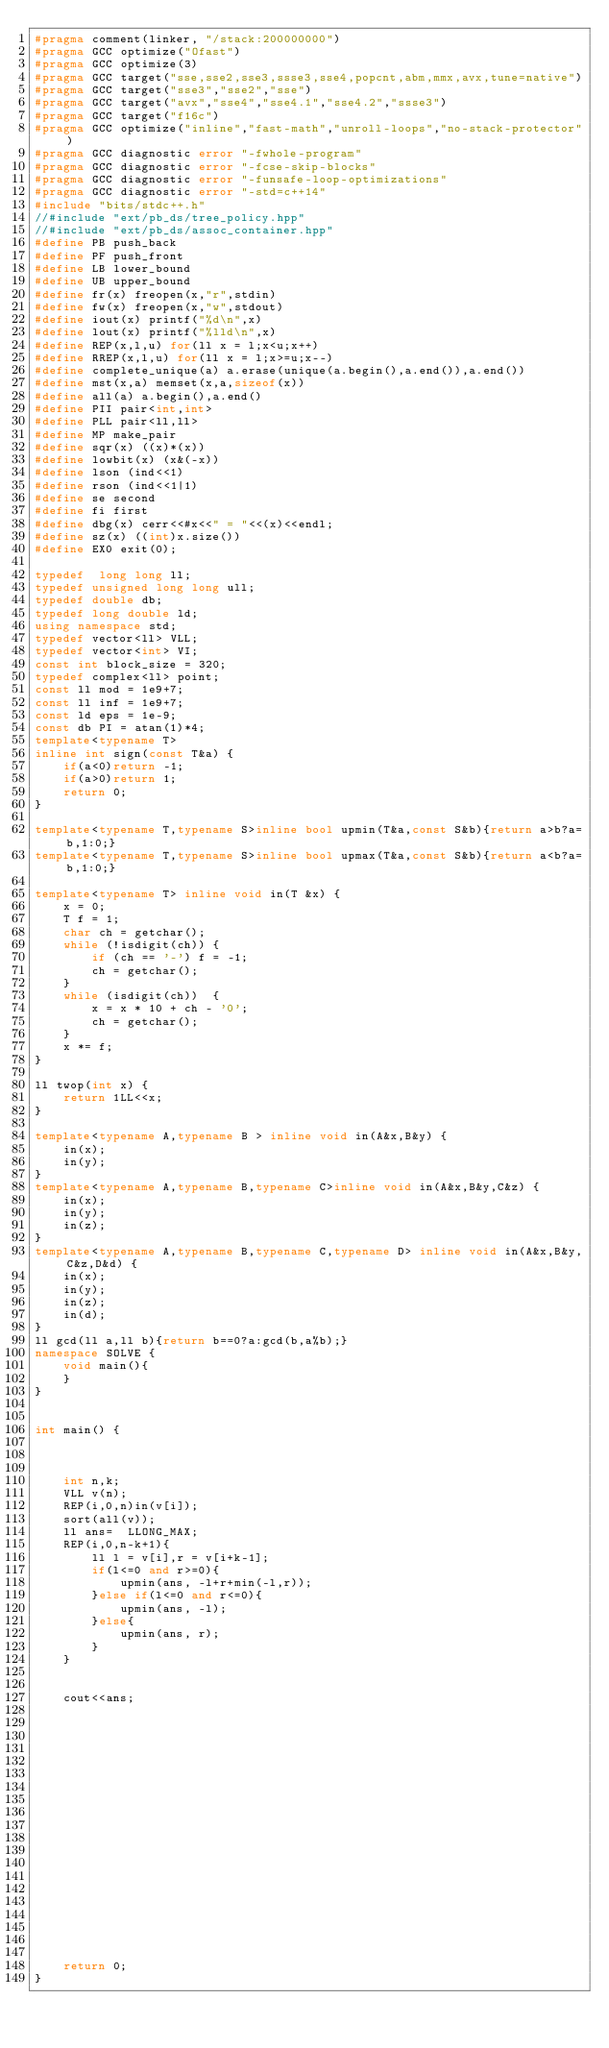<code> <loc_0><loc_0><loc_500><loc_500><_C++_>#pragma comment(linker, "/stack:200000000")
#pragma GCC optimize("Ofast")
#pragma GCC optimize(3)
#pragma GCC target("sse,sse2,sse3,ssse3,sse4,popcnt,abm,mmx,avx,tune=native")
#pragma GCC target("sse3","sse2","sse")
#pragma GCC target("avx","sse4","sse4.1","sse4.2","ssse3")
#pragma GCC target("f16c")
#pragma GCC optimize("inline","fast-math","unroll-loops","no-stack-protector")
#pragma GCC diagnostic error "-fwhole-program"
#pragma GCC diagnostic error "-fcse-skip-blocks"
#pragma GCC diagnostic error "-funsafe-loop-optimizations"
#pragma GCC diagnostic error "-std=c++14"
#include "bits/stdc++.h"
//#include "ext/pb_ds/tree_policy.hpp"
//#include "ext/pb_ds/assoc_container.hpp"
#define PB push_back
#define PF push_front
#define LB lower_bound
#define UB upper_bound
#define fr(x) freopen(x,"r",stdin)
#define fw(x) freopen(x,"w",stdout)
#define iout(x) printf("%d\n",x)
#define lout(x) printf("%lld\n",x)
#define REP(x,l,u) for(ll x = l;x<u;x++)
#define RREP(x,l,u) for(ll x = l;x>=u;x--)
#define complete_unique(a) a.erase(unique(a.begin(),a.end()),a.end())
#define mst(x,a) memset(x,a,sizeof(x))
#define all(a) a.begin(),a.end()
#define PII pair<int,int>
#define PLL pair<ll,ll>
#define MP make_pair
#define sqr(x) ((x)*(x))
#define lowbit(x) (x&(-x))
#define lson (ind<<1)
#define rson (ind<<1|1)
#define se second
#define fi first
#define dbg(x) cerr<<#x<<" = "<<(x)<<endl;
#define sz(x) ((int)x.size())
#define EX0 exit(0);

typedef  long long ll;
typedef unsigned long long ull;
typedef double db;
typedef long double ld;
using namespace std;
typedef vector<ll> VLL;
typedef vector<int> VI;
const int block_size = 320;
typedef complex<ll> point;
const ll mod = 1e9+7;
const ll inf = 1e9+7;
const ld eps = 1e-9;
const db PI = atan(1)*4;
template<typename T>
inline int sign(const T&a) {
    if(a<0)return -1;
    if(a>0)return 1;
    return 0;
}

template<typename T,typename S>inline bool upmin(T&a,const S&b){return a>b?a=b,1:0;}
template<typename T,typename S>inline bool upmax(T&a,const S&b){return a<b?a=b,1:0;}

template<typename T> inline void in(T &x) {
    x = 0;
    T f = 1;
    char ch = getchar();
    while (!isdigit(ch)) {
        if (ch == '-') f = -1;
        ch = getchar();
    }
    while (isdigit(ch))  {
        x = x * 10 + ch - '0';
        ch = getchar();
    }
    x *= f;
}

ll twop(int x) {
    return 1LL<<x;
}

template<typename A,typename B > inline void in(A&x,B&y) {
    in(x);
    in(y);
}
template<typename A,typename B,typename C>inline void in(A&x,B&y,C&z) {
    in(x);
    in(y);
    in(z);
}
template<typename A,typename B,typename C,typename D> inline void in(A&x,B&y,C&z,D&d) {
    in(x);
    in(y);
    in(z);
    in(d);
}
ll gcd(ll a,ll b){return b==0?a:gcd(b,a%b);}
namespace SOLVE {
    void main(){
    }
}


int main() {

    
    
    int n,k;
    VLL v(n);
    REP(i,0,n)in(v[i]);
    sort(all(v));
    ll ans=  LLONG_MAX;
    REP(i,0,n-k+1){
        ll l = v[i],r = v[i+k-1];
        if(l<=0 and r>=0){
            upmin(ans, -l+r+min(-l,r));
        }else if(l<=0 and r<=0){
            upmin(ans, -l);
        }else{
            upmin(ans, r);
        }
    }
    
    
    cout<<ans;
    
    
    
    
    
    
    
    
    
    
    
    
    
    
    
    
    
    
    
    
    return 0;
}
</code> 